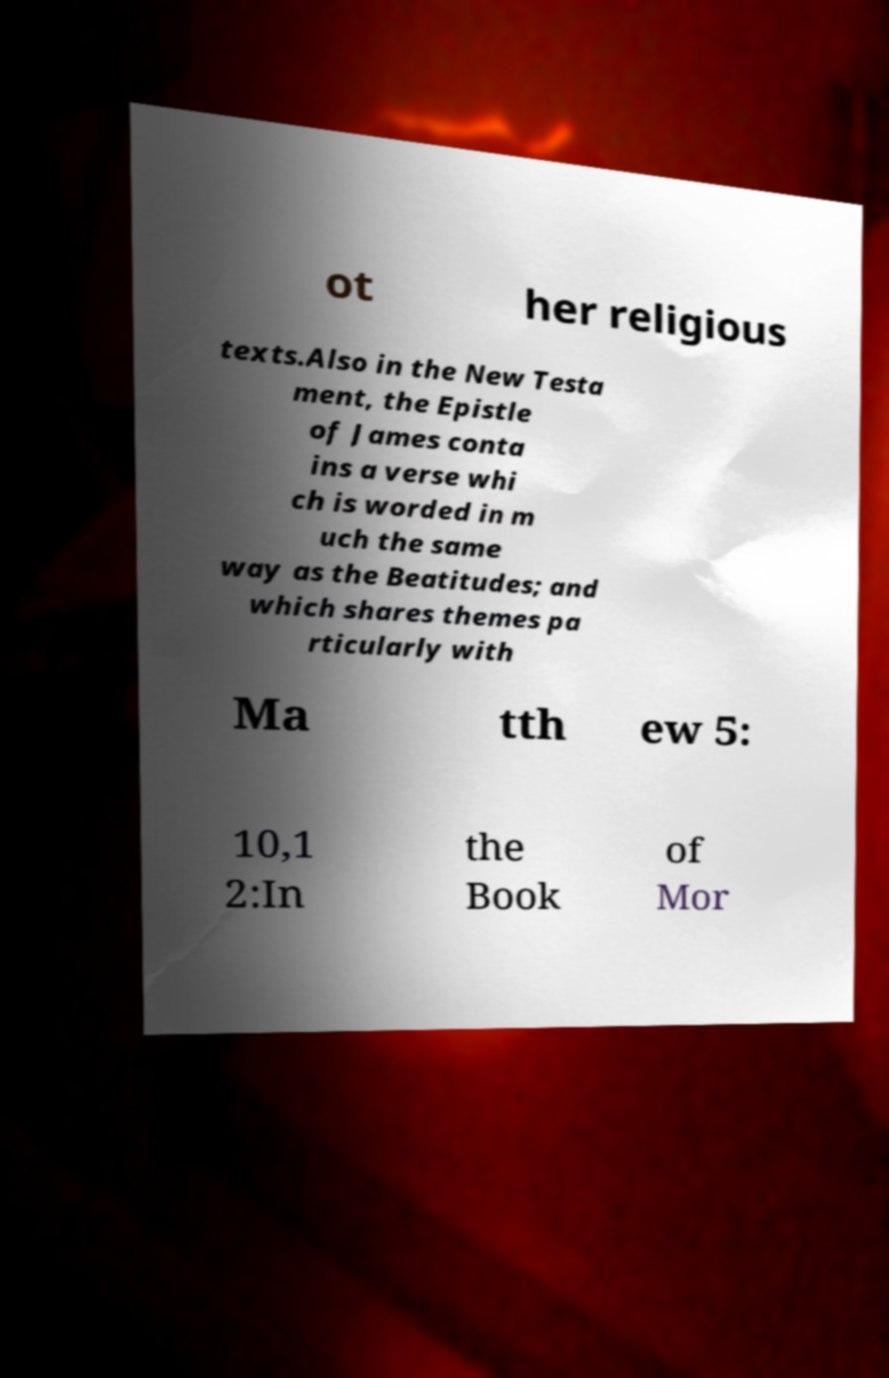For documentation purposes, I need the text within this image transcribed. Could you provide that? ot her religious texts.Also in the New Testa ment, the Epistle of James conta ins a verse whi ch is worded in m uch the same way as the Beatitudes; and which shares themes pa rticularly with Ma tth ew 5: 10,1 2:In the Book of Mor 